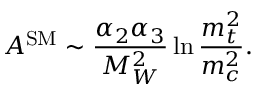Convert formula to latex. <formula><loc_0><loc_0><loc_500><loc_500>A ^ { S M } \sim \frac { \alpha _ { 2 } \alpha _ { 3 } } { M _ { W } ^ { 2 } } \ln \frac { m _ { t } ^ { 2 } } { m _ { c } ^ { 2 } } .</formula> 